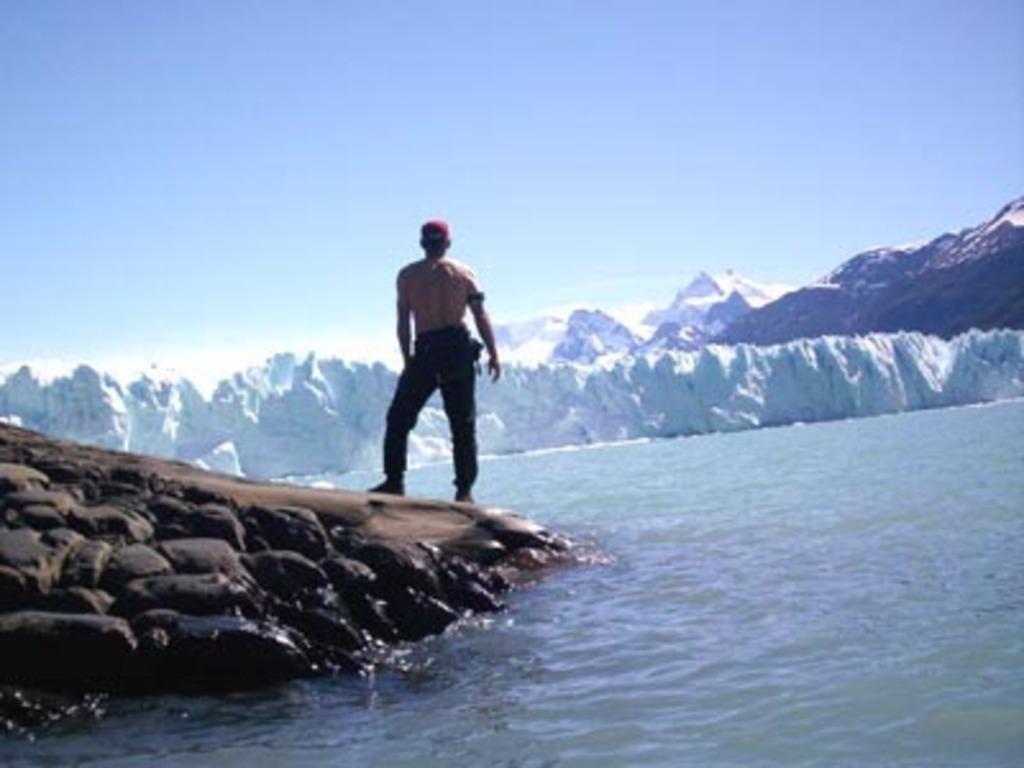Could you give a brief overview of what you see in this image? In the image we can see a man standing, he is wearing trouser, shoes and a cap. These are the stones, water, snow, mountain and a plane blue sky. 